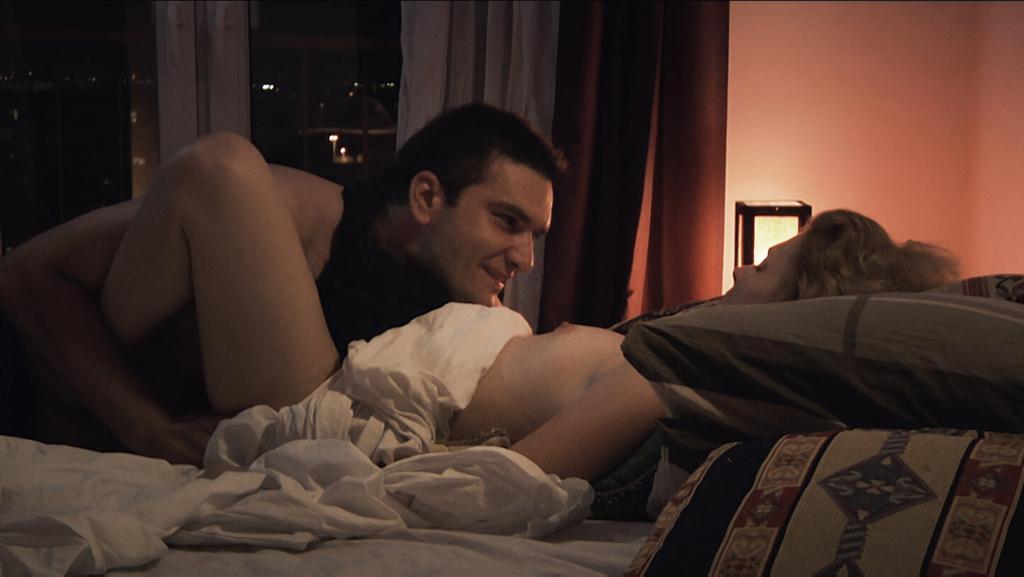Can you describe this image briefly? This is an inside view of a room. Here I can see a woman and a man are laying on a bed. There are few pillows and bed-sheets. In the background, I can see the curtains to the windows. On the right side there is a wall and a lamp. 